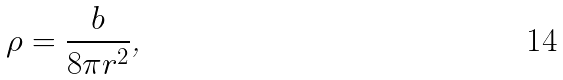Convert formula to latex. <formula><loc_0><loc_0><loc_500><loc_500>\rho = \frac { b } { 8 \pi r ^ { 2 } } \text {, }</formula> 